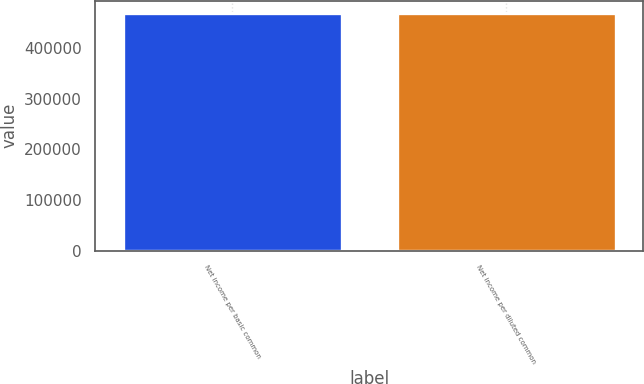<chart> <loc_0><loc_0><loc_500><loc_500><bar_chart><fcel>Net income per basic common<fcel>Net income per diluted common<nl><fcel>469053<fcel>469053<nl></chart> 